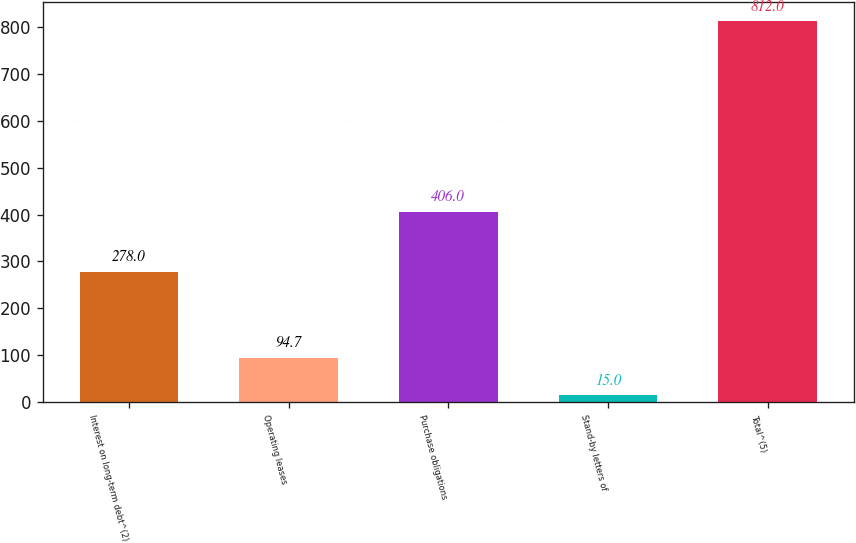<chart> <loc_0><loc_0><loc_500><loc_500><bar_chart><fcel>Interest on long-term debt^(2)<fcel>Operating leases<fcel>Purchase obligations<fcel>Stand-by letters of<fcel>Total^(5)<nl><fcel>278<fcel>94.7<fcel>406<fcel>15<fcel>812<nl></chart> 